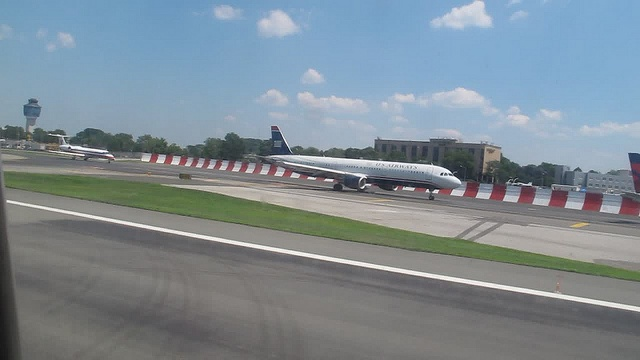Describe the objects in this image and their specific colors. I can see airplane in darkgray, gray, lightgray, and black tones and airplane in darkgray, gray, lightgray, and black tones in this image. 